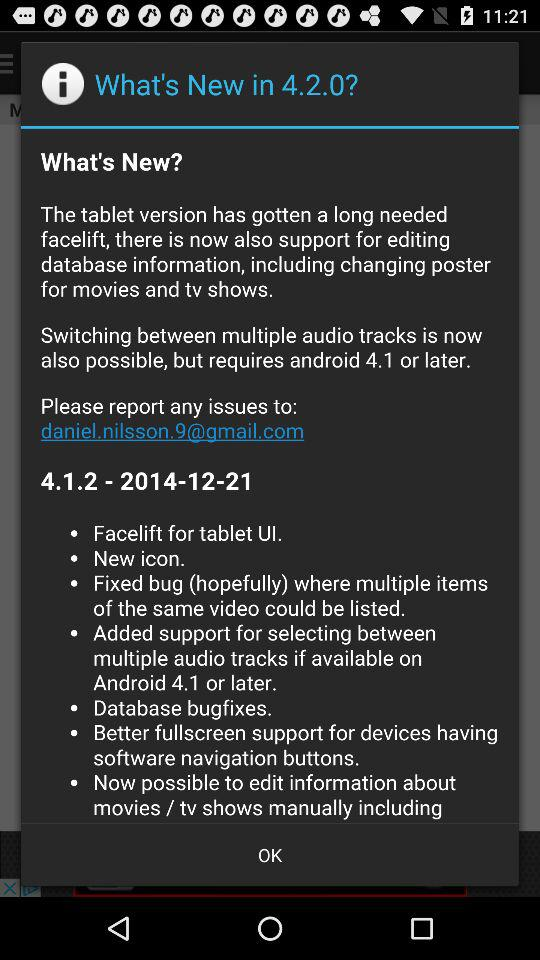What is the email address? The email address is daniel.nilsson.9@gmail.com. 